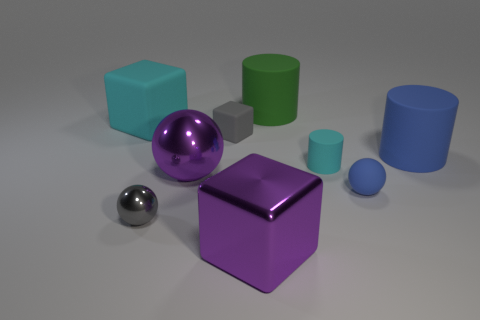Is the big blue object the same shape as the small gray rubber object?
Ensure brevity in your answer.  No. How many objects are left of the big blue cylinder and in front of the green cylinder?
Your answer should be compact. 7. Are there the same number of small objects to the right of the cyan matte cylinder and large cyan rubber things that are to the right of the small gray ball?
Ensure brevity in your answer.  No. Is the size of the metal sphere in front of the small matte sphere the same as the matte cylinder right of the tiny blue sphere?
Your answer should be very brief. No. There is a small thing that is both in front of the small gray matte block and behind the small rubber ball; what is it made of?
Offer a terse response. Rubber. Is the number of big purple balls less than the number of big gray matte things?
Your answer should be compact. No. What size is the blue thing in front of the blue rubber thing that is on the right side of the small rubber ball?
Provide a short and direct response. Small. What shape is the cyan rubber thing that is to the right of the cylinder left of the tiny cylinder behind the small gray shiny ball?
Offer a terse response. Cylinder. What color is the small thing that is made of the same material as the large purple sphere?
Your answer should be compact. Gray. There is a ball that is right of the rubber cylinder in front of the large matte thing that is in front of the gray matte thing; what is its color?
Make the answer very short. Blue. 